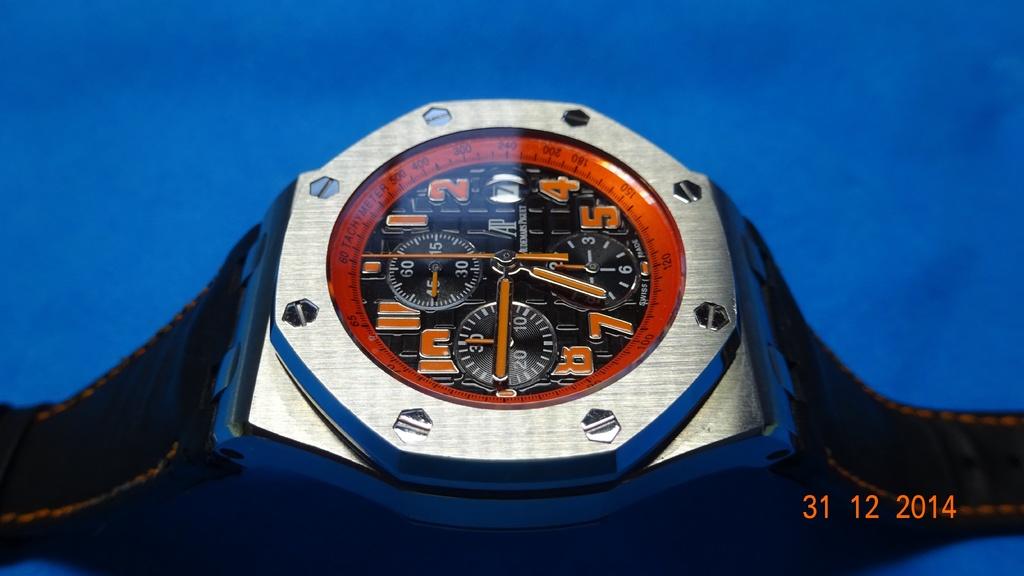The date on the picture is?
Your response must be concise. 31 12 2014. When was this picture taken?
Offer a terse response. 31 12 2014. 